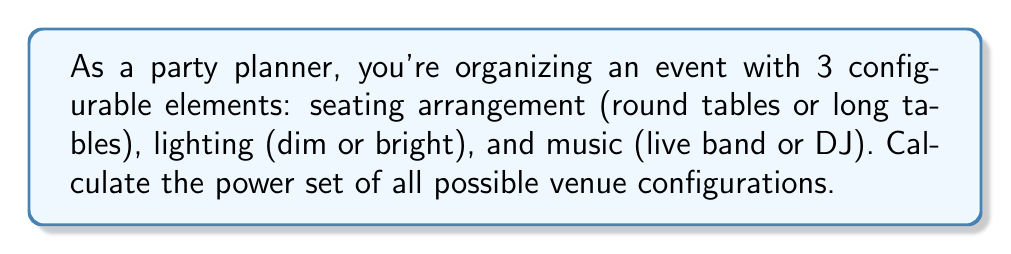What is the answer to this math problem? Let's approach this step-by-step:

1) First, let's define our set of venue configurations:
   Let S = {seating, lighting, music}
   
   Each element has 2 options:
   - seating: round tables (R) or long tables (L)
   - lighting: dim (D) or bright (B)
   - music: live band (V) or DJ (J)

2) To find the power set, we need to list all possible subsets, including the empty set and the set itself.

3) The number of elements in the power set is given by the formula:
   $$ 2^n $$
   where n is the number of elements in the original set.

4) In this case, n = 3, so the power set will have $2^3 = 8$ elements.

5) Let's list all possible configurations:
   - {} (empty set)
   - {R} (only round tables)
   - {D} (only dim lighting)
   - {V} (only live band)
   - {R,D} (round tables and dim lighting)
   - {R,V} (round tables and live band)
   - {D,V} (dim lighting and live band)
   - {R,D,V} (round tables, dim lighting, and live band)

6) The power set is the set of all these subsets.

7) Note that we've only listed one option for each element. The other options (L, B, J) are implied as the alternative when an element is not included in a subset.
Answer: The power set of possible venue configurations is:

$$ P(S) = \{ \{\}, \{R\}, \{D\}, \{V\}, \{R,D\}, \{R,V\}, \{D,V\}, \{R,D,V\} \} $$

Where R = round tables, D = dim lighting, V = live band. 